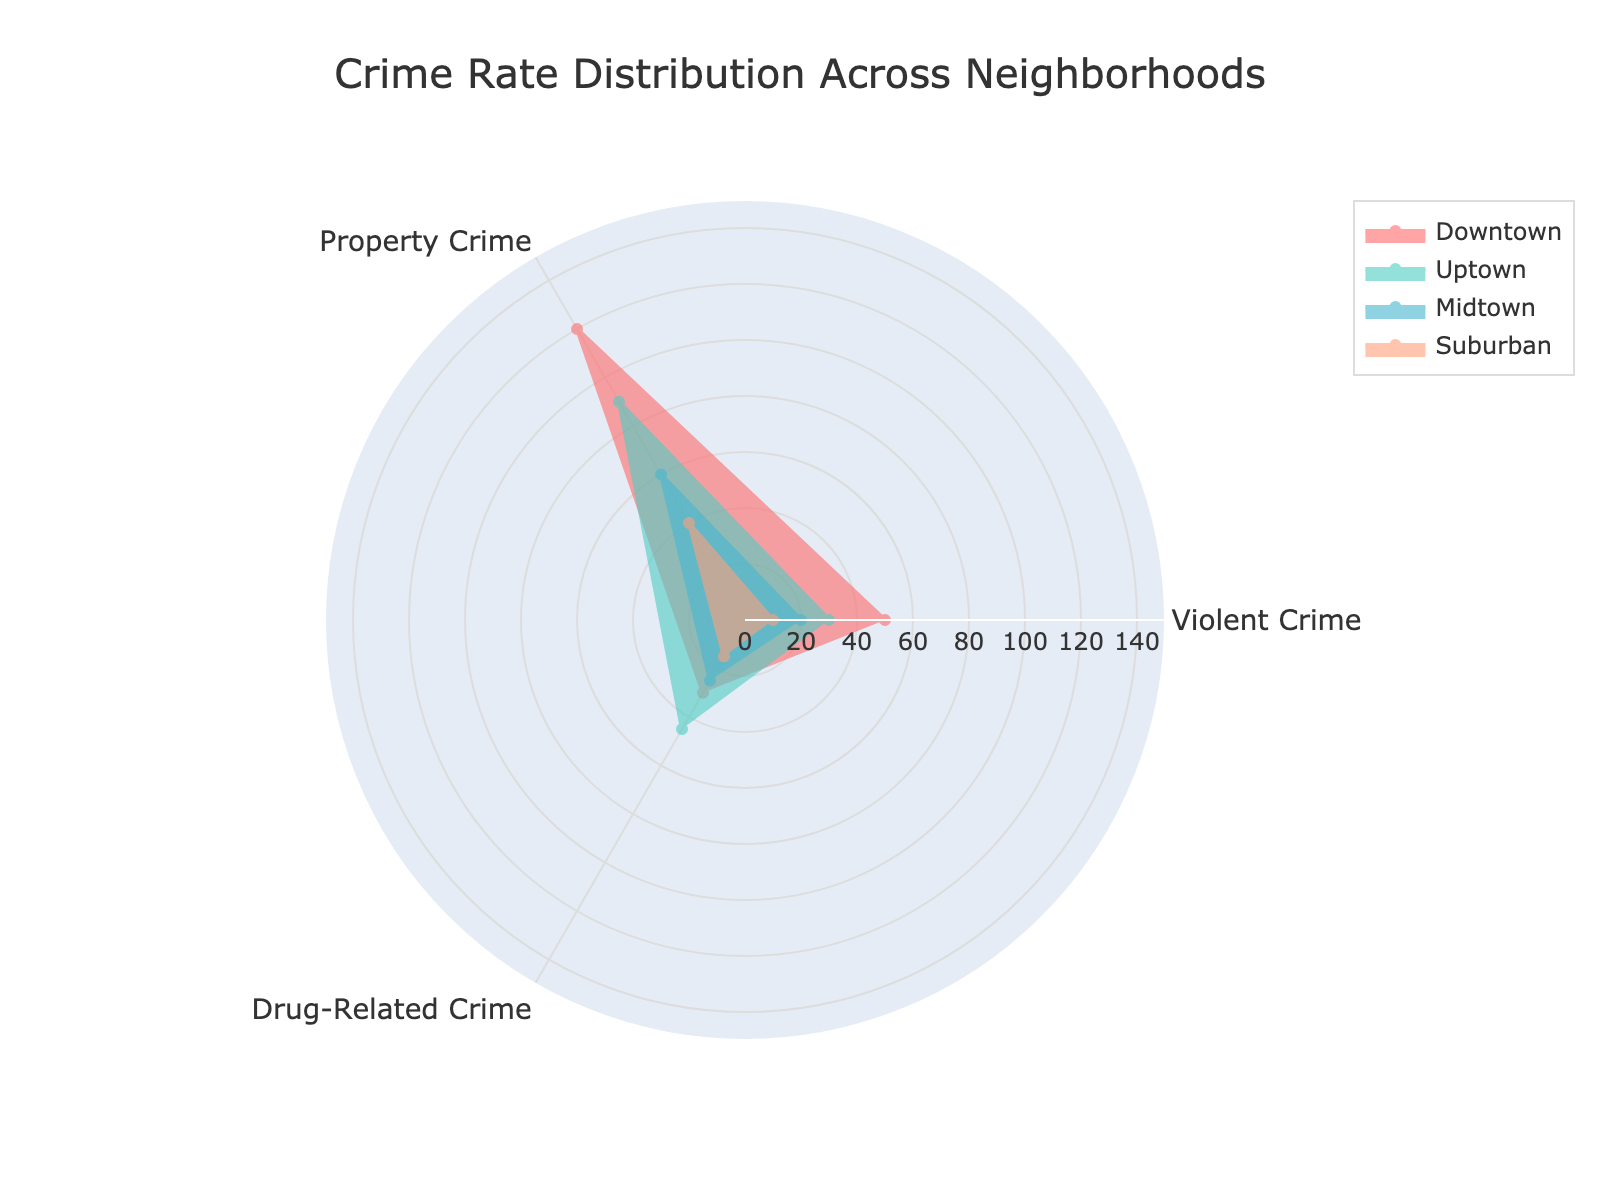Which neighborhood has the highest rate of violent crime? Look at the section of the radar chart representing violent crime and identify the neighborhood with the largest distance.
Answer: Downtown What is the combined rate of property crime for Uptown and Midtown? For Uptown, property crime is 90, and for Midtown, it is 60. Summing these values gives 150.
Answer: 150 How does the rate of drug-related crime in Suburban compare to that in Uptown? The rate of drug-related crime in Suburban is 15, and in Uptown, it is 45. Compare these values to determine that Suburban has less drug-related crime than Uptown.
Answer: Suburban has less Which type of crime is most prevalent in Midtown? Look at the radar chart for Midtown and identify the highest value among violent crime, property crime, and drug-related crime.
Answer: Property Crime Which neighborhood has the lowest rate of property crime? Compare the property crime rates for Downtown, Uptown, Midtown, and Suburban. Suburban has the lowest rate at 40.
Answer: Suburban What is the difference between the highest and lowest rates of violent crime among the neighborhoods? The highest rate of violent crime is in Downtown (50) and the lowest is in Suburban (10). The difference is 50 - 10.
Answer: 40 Across all neighborhoods, which type of crime is generally the least frequent? Look at the radar chart and compare the frequencies of violent crime, property crime, and drug-related crime in all neighborhoods. Drug-related crime is generally the least frequent.
Answer: Drug-Related Crime Which neighborhood has the highest overall crime rate when combining violent, property, and drug-related crimes? Sum the values for each crime type for all neighborhoods. Downtown has the highest overall (50 + 120 + 30 = 200).
Answer: Downtown 